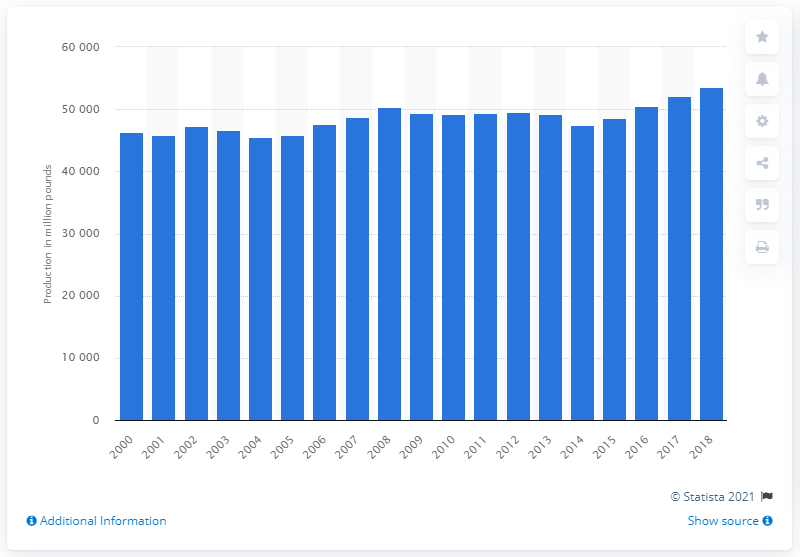Give some essential details in this illustration. In 2018, the United States produced a total of 53,507 million pounds of red meat. 